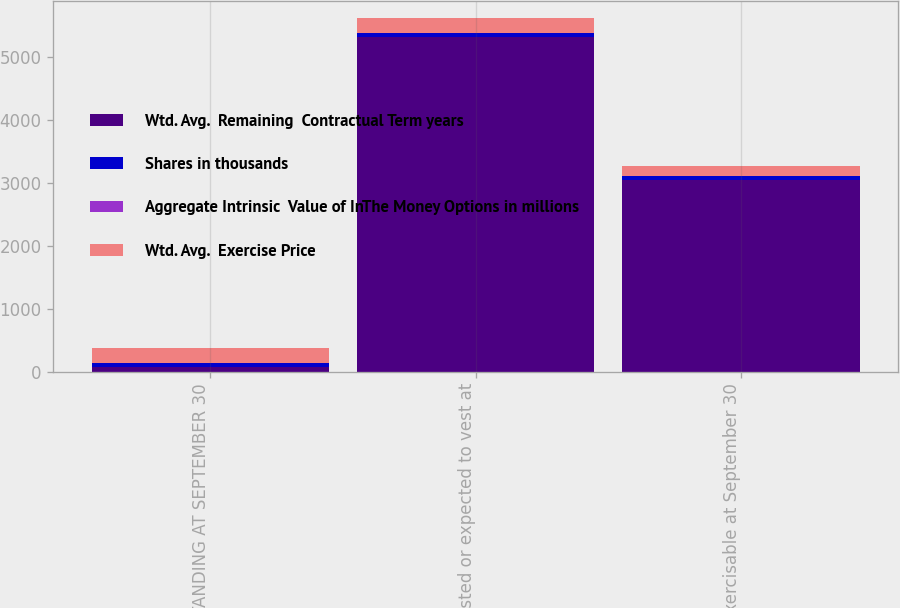Convert chart to OTSL. <chart><loc_0><loc_0><loc_500><loc_500><stacked_bar_chart><ecel><fcel>OUTSTANDING AT SEPTEMBER 30<fcel>Vested or expected to vest at<fcel>Exercisable at September 30<nl><fcel>Wtd. Avg.  Remaining  Contractual Term years<fcel>64.53<fcel>5311<fcel>3048<nl><fcel>Shares in thousands<fcel>64.53<fcel>64.15<fcel>55.4<nl><fcel>Aggregate Intrinsic  Value of InThe Money Options in millions<fcel>6.9<fcel>6.8<fcel>5.6<nl><fcel>Wtd. Avg.  Exercise Price<fcel>232.7<fcel>227.3<fcel>157.1<nl></chart> 